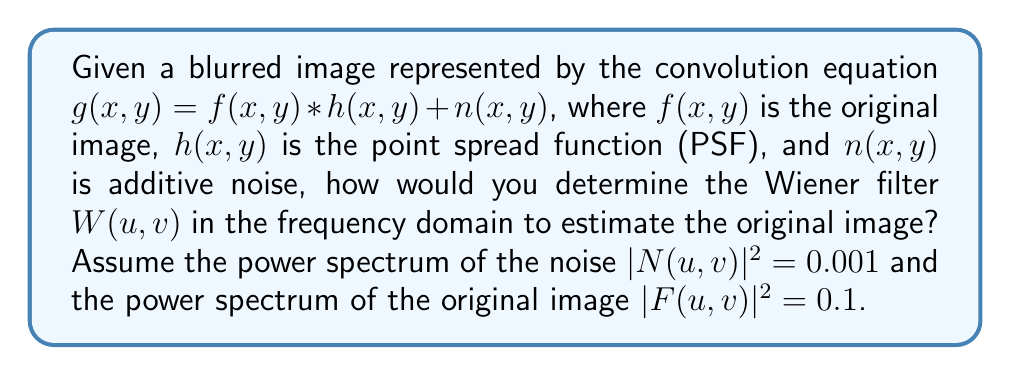Give your solution to this math problem. To determine the Wiener filter for image deconvolution, we follow these steps:

1) The Wiener filter in the frequency domain is given by:

   $$W(u,v) = \frac{H^*(u,v)}{|H(u,v)|^2 + \frac{S_n(u,v)}{S_f(u,v)}}$$

   where $H(u,v)$ is the Fourier transform of the PSF, $H^*(u,v)$ is its complex conjugate, $S_n(u,v)$ is the power spectrum of the noise, and $S_f(u,v)$ is the power spectrum of the original image.

2) We are given that $|N(u,v)|^2 = 0.001$ and $|F(u,v)|^2 = 0.1$. These represent $S_n(u,v)$ and $S_f(u,v)$ respectively.

3) Substituting these values into the Wiener filter equation:

   $$W(u,v) = \frac{H^*(u,v)}{|H(u,v)|^2 + \frac{0.001}{0.1}}$$

4) Simplify the fraction in the denominator:

   $$W(u,v) = \frac{H^*(u,v)}{|H(u,v)|^2 + 0.01}$$

5) This is the final form of the Wiener filter for this specific case. To apply it, you would multiply this filter with the Fourier transform of the blurred image in the frequency domain, then perform an inverse Fourier transform to obtain the estimated original image.

As a security-focused programmer, understanding this process can help in implementing robust image processing algorithms that maintain data integrity and protect against potential vulnerabilities in image manipulation systems.
Answer: $$W(u,v) = \frac{H^*(u,v)}{|H(u,v)|^2 + 0.01}$$ 